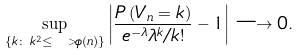Convert formula to latex. <formula><loc_0><loc_0><loc_500><loc_500>\sup _ { \{ k \colon \, k ^ { 2 } \leq \ > \phi ( n ) \} } \left | \frac { P \left ( V _ { n } = k \right ) } { e ^ { - \lambda } \lambda ^ { k } / k ! } - 1 \right | \longrightarrow 0 .</formula> 